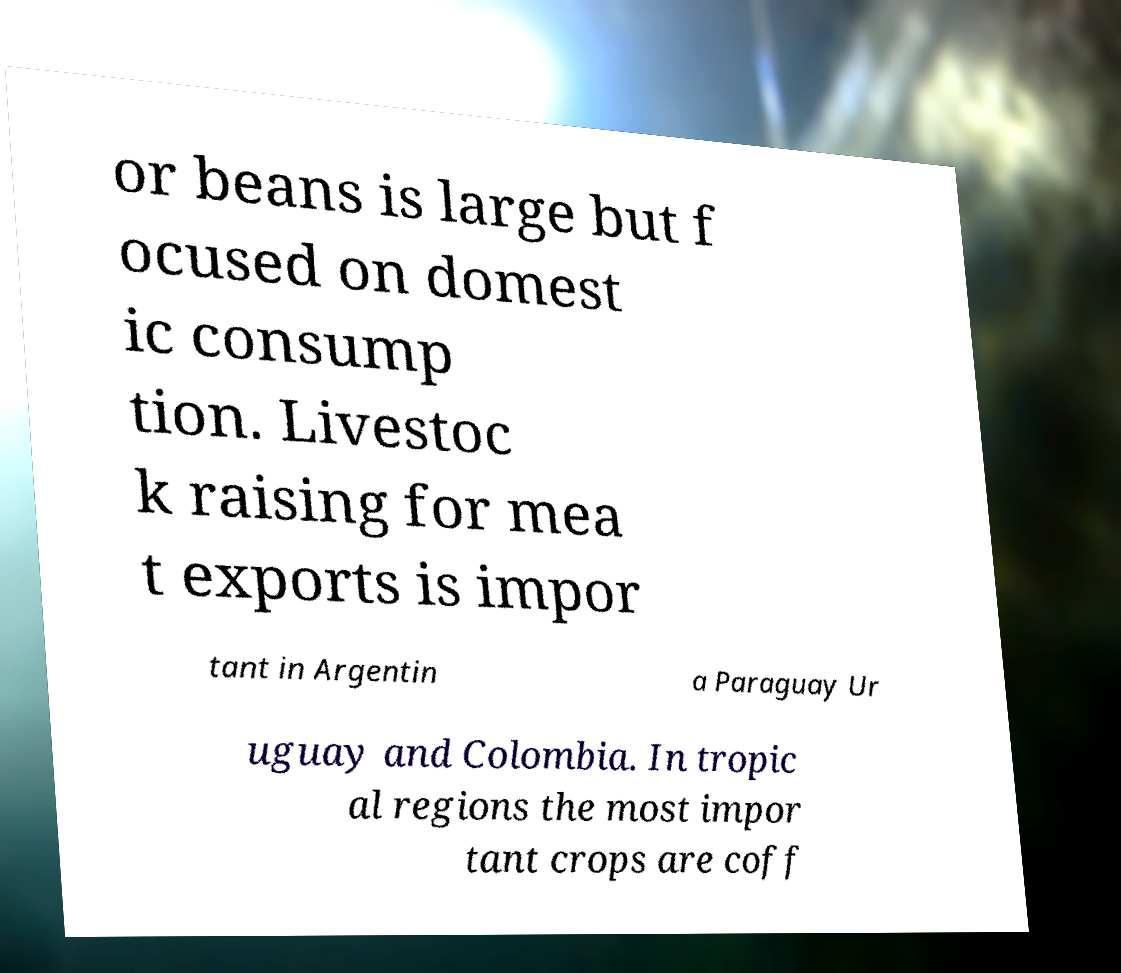What messages or text are displayed in this image? I need them in a readable, typed format. or beans is large but f ocused on domest ic consump tion. Livestoc k raising for mea t exports is impor tant in Argentin a Paraguay Ur uguay and Colombia. In tropic al regions the most impor tant crops are coff 